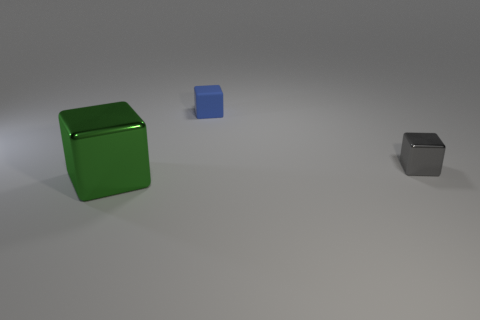What shape is the shiny object to the left of the rubber object?
Your answer should be very brief. Cube. Is the tiny gray thing made of the same material as the large block?
Give a very brief answer. Yes. Is there any other thing that has the same size as the green cube?
Your answer should be compact. No. There is a matte thing; what number of cubes are behind it?
Make the answer very short. 0. There is a shiny object behind the metal thing that is in front of the gray metallic cube; what shape is it?
Offer a very short reply. Cube. Are there more metallic things left of the small blue thing than yellow spheres?
Keep it short and to the point. Yes. What number of blue matte things are on the left side of the shiny thing that is behind the large green metal object?
Give a very brief answer. 1. There is a thing that is to the left of the cube behind the shiny object to the right of the large green block; what shape is it?
Give a very brief answer. Cube. The gray thing is what size?
Ensure brevity in your answer.  Small. Is there a small gray object that has the same material as the big green block?
Your answer should be very brief. Yes. 